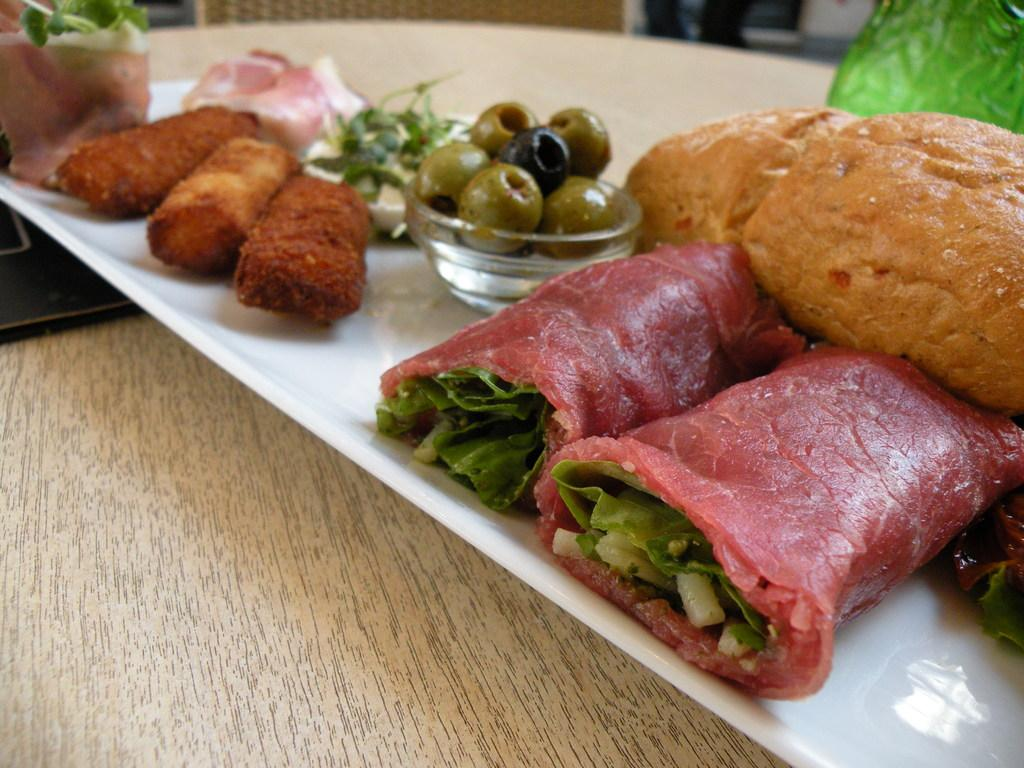What is on the plate that is visible in the image? The plate contains fruits and other food items. What type of food items can be seen on the plate? The plate contains fruits, which are a type of food item. Where is the plate located in the image? The plate is on a table at the bottom of the image. What else can be seen in the image besides the plate and food items? There are objects visible in the background of the image. What type of tooth is visible in the image? There is no tooth present in the image. How is the wrench being used in the image? There is no wrench present in the image. 